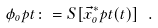<formula> <loc_0><loc_0><loc_500><loc_500>\phi _ { o } p t \colon = S [ \vec { x } ^ { \ast } _ { o } p t ( t ) ] \ .</formula> 